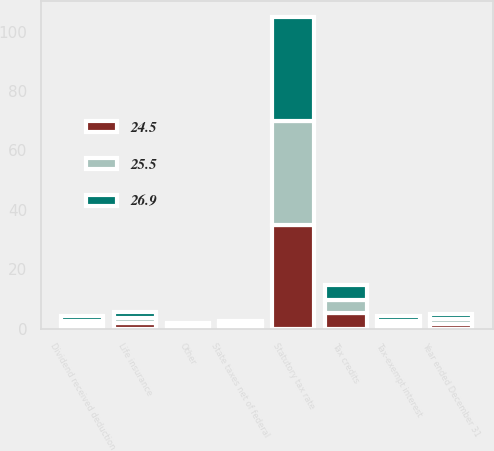Convert chart to OTSL. <chart><loc_0><loc_0><loc_500><loc_500><stacked_bar_chart><ecel><fcel>Year ended December 31<fcel>Statutory tax rate<fcel>State taxes net of federal<fcel>Tax-exempt interest<fcel>Life insurance<fcel>Dividend received deduction<fcel>Tax credits<fcel>Other<nl><fcel>26.9<fcel>1.6<fcel>35<fcel>0.4<fcel>1.7<fcel>2<fcel>1.6<fcel>5.1<fcel>0.5<nl><fcel>25.5<fcel>1.6<fcel>35<fcel>0.8<fcel>1.3<fcel>1.8<fcel>1.4<fcel>4.3<fcel>1<nl><fcel>24.5<fcel>1.6<fcel>35<fcel>1.2<fcel>1.2<fcel>1.9<fcel>1.2<fcel>5.4<fcel>0.4<nl></chart> 